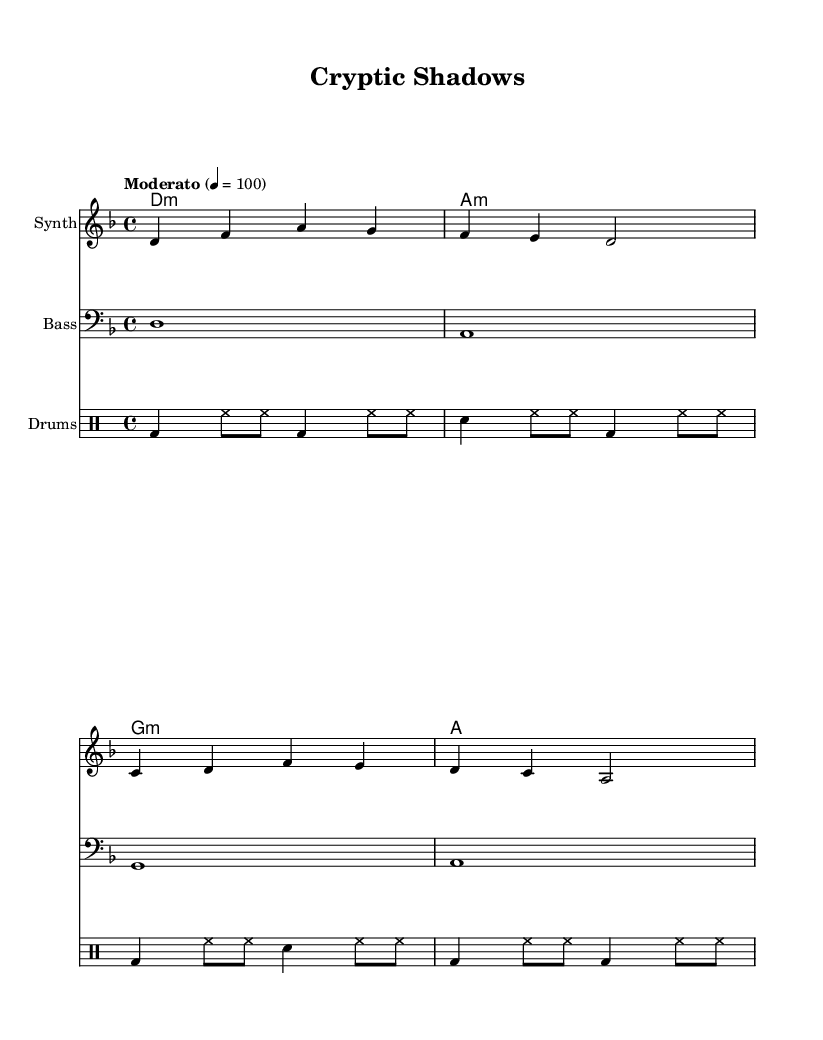What is the key signature of this music? The key signature is indicated by the number of sharps or flats at the beginning of the staff. In this case, the presence of one flat indicates that the key signature is D minor.
Answer: D minor What is the time signature of this music? The time signature is found at the beginning of the score, represented as a fraction. Here, it is shown as 4/4, indicating four beats per measure.
Answer: 4/4 What is the tempo marking for this piece? The tempo marking can usually be found at the beginning of the score, specifying the speed of the performance. This score indicates a tempo of moderato, at 100 beats per minute.
Answer: Moderato, 100 How many measures are in the Synth part? The measures are divided by vertical lines on the staff. Counting these lines in the Synth part, there are a total of four measures.
Answer: 4 Which chord is played in the first measure of the harmonies? The chord used in the first measure can be identified by the notation at the beginning. The first measure shows a D minor chord, which is indicated by the symbol "d:m".
Answer: D minor What type of drum is represented by 'bd' in the drum score? The abbreviation 'bd' in the drum score stands for bass drum, which is a common percussion instrument used to provide a low, rhythmic foundation.
Answer: Bass drum What is the last note played in the Bass staff? The last note in the Bass part can be found by looking at the final measure in that staff. The last note is an A, indicated in the notation.
Answer: A 